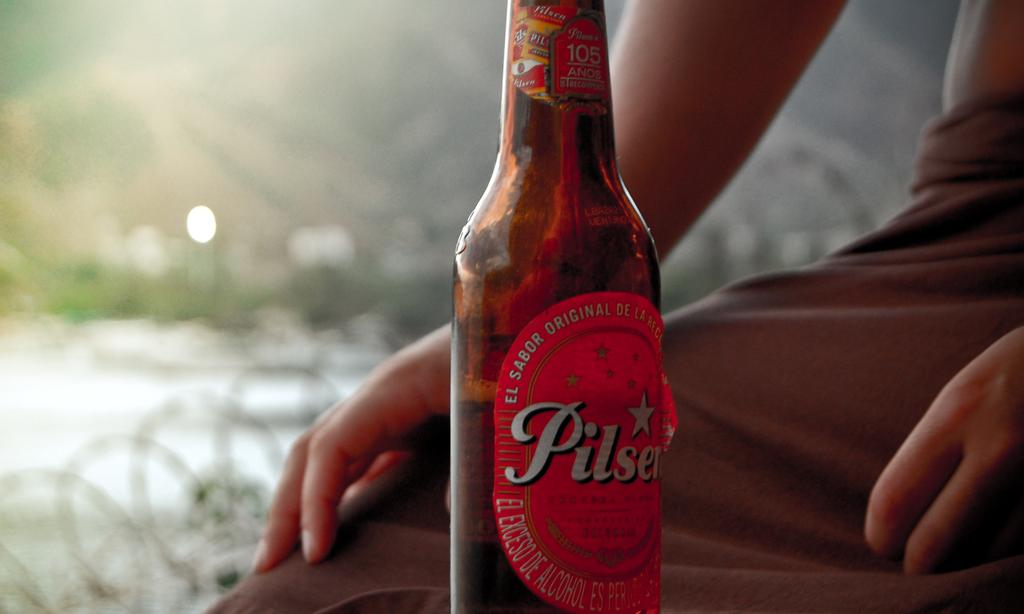What object is featured in the image? There is a bottle in the image. How is the bottle being emphasized? The bottle is highlighted in the image. Is there any additional information about the bottle? Yes, there is a sticker on the bottle. Who is present in the image? A person is sitting beside the bottle. What type of scissors can be seen cutting the sidewalk in the image? There are no scissors or sidewalk present in the image; it features a bottle with a sticker and a person sitting beside it. 